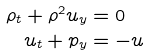<formula> <loc_0><loc_0><loc_500><loc_500>\rho _ { t } + \rho ^ { 2 } u _ { y } & = 0 \\ u _ { t } + p _ { y } & = - u</formula> 